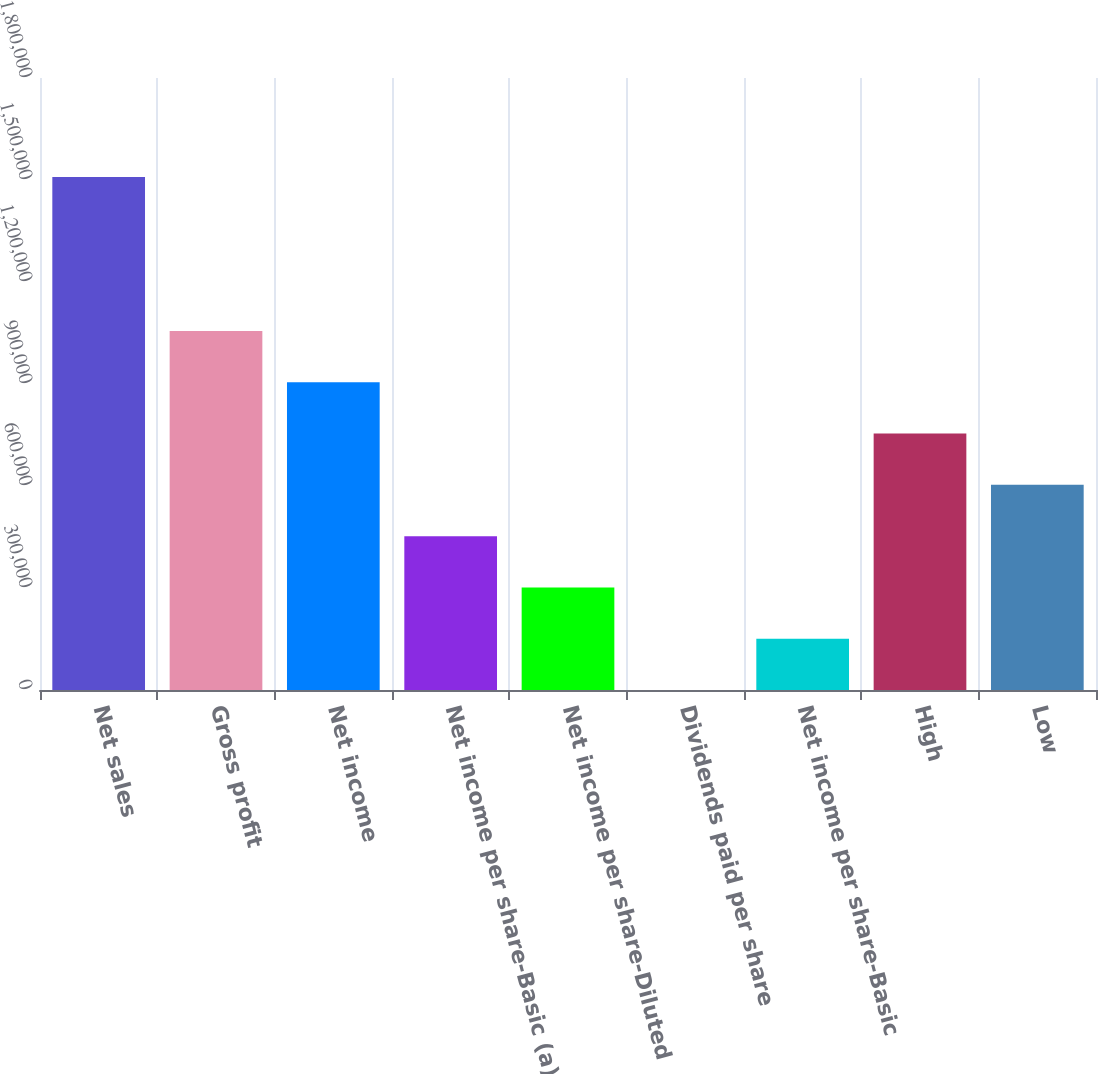<chart> <loc_0><loc_0><loc_500><loc_500><bar_chart><fcel>Net sales<fcel>Gross profit<fcel>Net income<fcel>Net income per share-Basic (a)<fcel>Net income per share-Diluted<fcel>Dividends paid per share<fcel>Net income per share-Basic<fcel>High<fcel>Low<nl><fcel>1.50851e+06<fcel>1.05596e+06<fcel>905109<fcel>452554<fcel>301703<fcel>0.42<fcel>150852<fcel>754257<fcel>603406<nl></chart> 